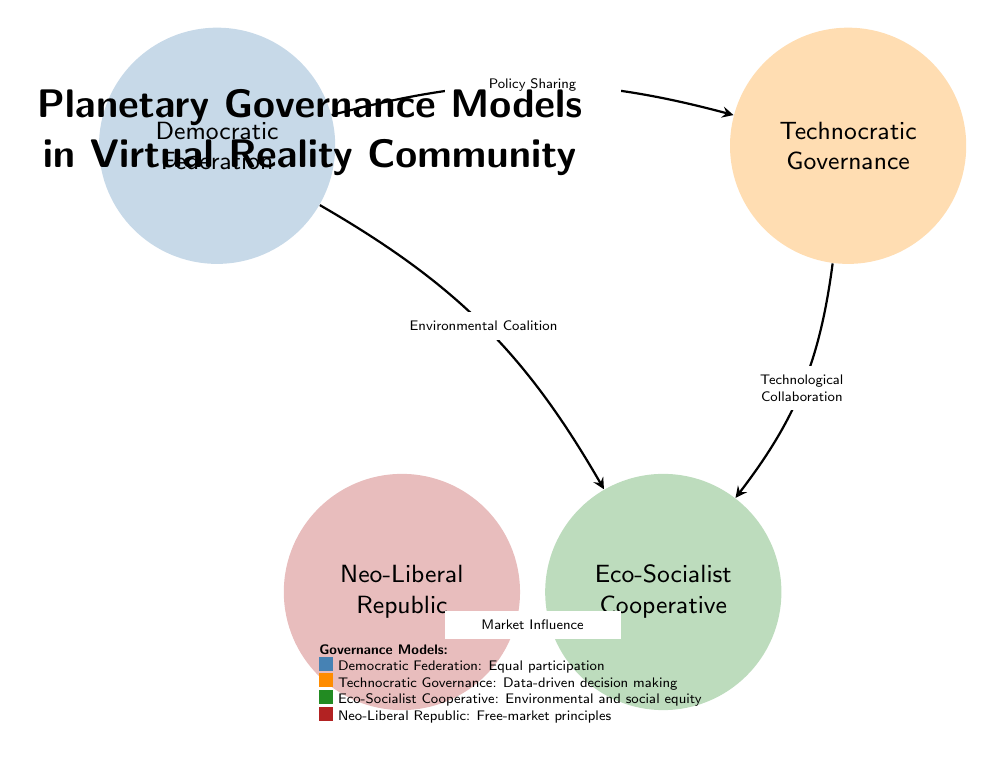What are the four governance models depicted in the diagram? The four governance models are labeled in the diagram and can be clearly identified: Democratic Federation, Technocratic Governance, Eco-Socialist Cooperative, and Neo-Liberal Republic.
Answer: Democratic Federation, Technocratic Governance, Eco-Socialist Cooperative, Neo-Liberal Republic How many connections are shown in the diagram? By counting the arrows that connect the different governance models, we find there are four connections: Policy Sharing, Technological Collaboration, Market Influence, and Environmental Coalition.
Answer: 4 What influences the Eco-Socialist Cooperative according to the diagram? Eco-Socialist Cooperative is influenced by two connections: Market Influence from Neo-Liberal Republic and Environmental Coalition from Democratic Federation, indicating influences from both the economic and environmental perspectives.
Answer: Market Influence, Environmental Coalition Which governance model has a connection labeled as "Technological Collaboration"? The Technocratic Governance model has a connection to the Eco-Socialist Cooperative model labeled as "Technological Collaboration", indicating a flow of decision-making based on technology between these two governance structures.
Answer: Technocratic Governance What color represents the Eco-Socialist Cooperative in the diagram? In the diagram, the Eco-Socialist Cooperative is represented by a specific color, which is easily identifiable by looking at the filled circle corresponding to this governance model. Its color is green, specifically Eco-Socialist Cooperative.
Answer: Green 